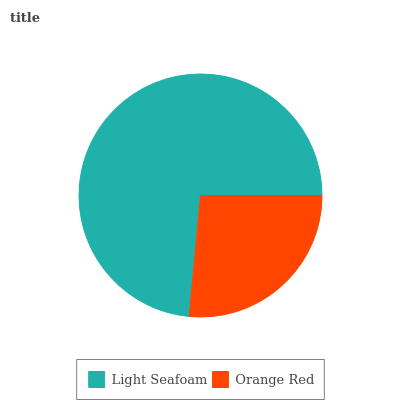Is Orange Red the minimum?
Answer yes or no. Yes. Is Light Seafoam the maximum?
Answer yes or no. Yes. Is Orange Red the maximum?
Answer yes or no. No. Is Light Seafoam greater than Orange Red?
Answer yes or no. Yes. Is Orange Red less than Light Seafoam?
Answer yes or no. Yes. Is Orange Red greater than Light Seafoam?
Answer yes or no. No. Is Light Seafoam less than Orange Red?
Answer yes or no. No. Is Light Seafoam the high median?
Answer yes or no. Yes. Is Orange Red the low median?
Answer yes or no. Yes. Is Orange Red the high median?
Answer yes or no. No. Is Light Seafoam the low median?
Answer yes or no. No. 